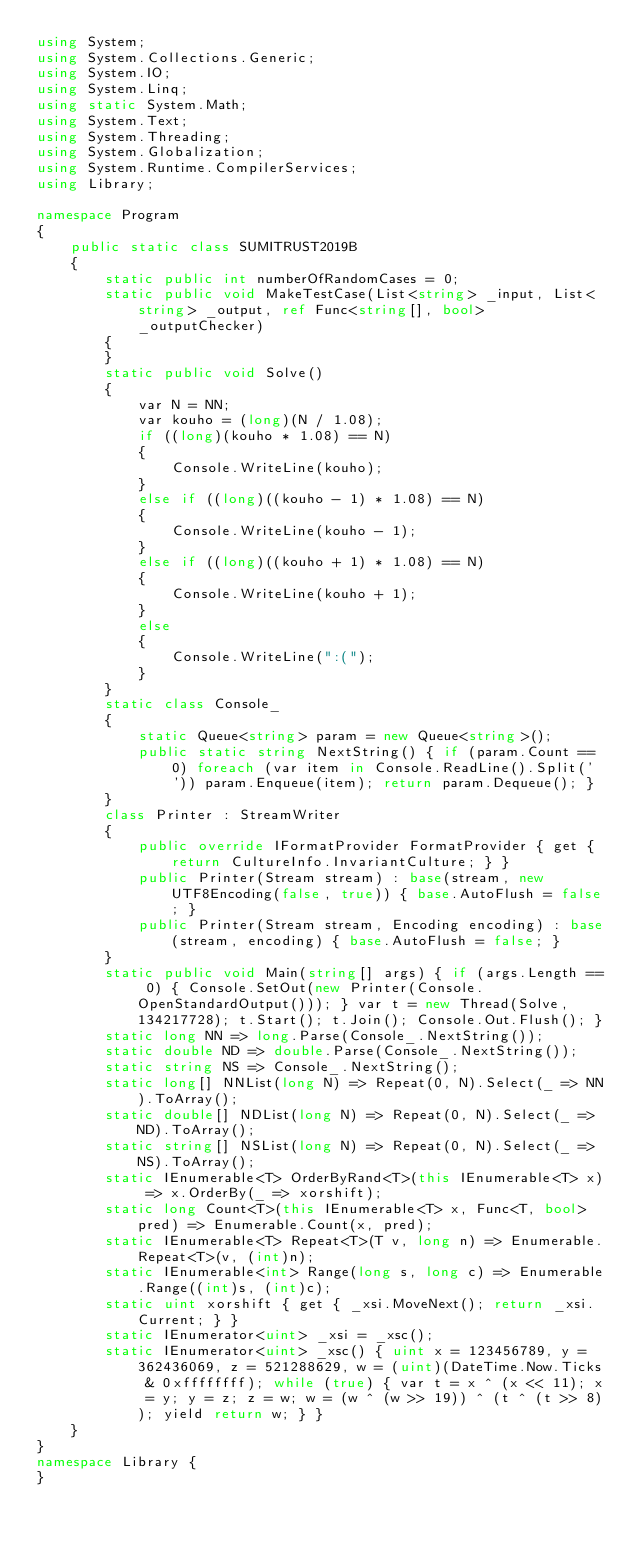<code> <loc_0><loc_0><loc_500><loc_500><_C#_>using System;
using System.Collections.Generic;
using System.IO;
using System.Linq;
using static System.Math;
using System.Text;
using System.Threading;
using System.Globalization;
using System.Runtime.CompilerServices;
using Library;

namespace Program
{
    public static class SUMITRUST2019B
    {
        static public int numberOfRandomCases = 0;
        static public void MakeTestCase(List<string> _input, List<string> _output, ref Func<string[], bool> _outputChecker)
        {
        }
        static public void Solve()
        {
            var N = NN;
            var kouho = (long)(N / 1.08);
            if ((long)(kouho * 1.08) == N)
            {
                Console.WriteLine(kouho);
            }
            else if ((long)((kouho - 1) * 1.08) == N)
            {
                Console.WriteLine(kouho - 1);
            }
            else if ((long)((kouho + 1) * 1.08) == N)
            {
                Console.WriteLine(kouho + 1);
            }
            else
            {
                Console.WriteLine(":(");
            }
        }
        static class Console_
        {
            static Queue<string> param = new Queue<string>();
            public static string NextString() { if (param.Count == 0) foreach (var item in Console.ReadLine().Split(' ')) param.Enqueue(item); return param.Dequeue(); }
        }
        class Printer : StreamWriter
        {
            public override IFormatProvider FormatProvider { get { return CultureInfo.InvariantCulture; } }
            public Printer(Stream stream) : base(stream, new UTF8Encoding(false, true)) { base.AutoFlush = false; }
            public Printer(Stream stream, Encoding encoding) : base(stream, encoding) { base.AutoFlush = false; }
        }
        static public void Main(string[] args) { if (args.Length == 0) { Console.SetOut(new Printer(Console.OpenStandardOutput())); } var t = new Thread(Solve, 134217728); t.Start(); t.Join(); Console.Out.Flush(); }
        static long NN => long.Parse(Console_.NextString());
        static double ND => double.Parse(Console_.NextString());
        static string NS => Console_.NextString();
        static long[] NNList(long N) => Repeat(0, N).Select(_ => NN).ToArray();
        static double[] NDList(long N) => Repeat(0, N).Select(_ => ND).ToArray();
        static string[] NSList(long N) => Repeat(0, N).Select(_ => NS).ToArray();
        static IEnumerable<T> OrderByRand<T>(this IEnumerable<T> x) => x.OrderBy(_ => xorshift);
        static long Count<T>(this IEnumerable<T> x, Func<T, bool> pred) => Enumerable.Count(x, pred);
        static IEnumerable<T> Repeat<T>(T v, long n) => Enumerable.Repeat<T>(v, (int)n);
        static IEnumerable<int> Range(long s, long c) => Enumerable.Range((int)s, (int)c);
        static uint xorshift { get { _xsi.MoveNext(); return _xsi.Current; } }
        static IEnumerator<uint> _xsi = _xsc();
        static IEnumerator<uint> _xsc() { uint x = 123456789, y = 362436069, z = 521288629, w = (uint)(DateTime.Now.Ticks & 0xffffffff); while (true) { var t = x ^ (x << 11); x = y; y = z; z = w; w = (w ^ (w >> 19)) ^ (t ^ (t >> 8)); yield return w; } }
    }
}
namespace Library {
}
</code> 